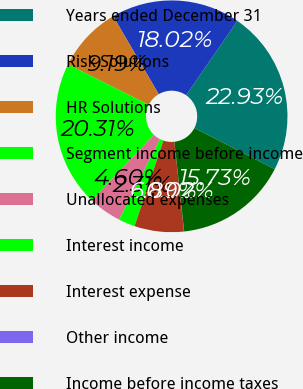Convert chart. <chart><loc_0><loc_0><loc_500><loc_500><pie_chart><fcel>Years ended December 31<fcel>Risk Solutions<fcel>HR Solutions<fcel>Segment income before income<fcel>Unallocated expenses<fcel>Interest income<fcel>Interest expense<fcel>Other income<fcel>Income before income taxes<nl><fcel>22.93%<fcel>18.02%<fcel>9.19%<fcel>20.31%<fcel>4.6%<fcel>2.31%<fcel>6.89%<fcel>0.02%<fcel>15.73%<nl></chart> 